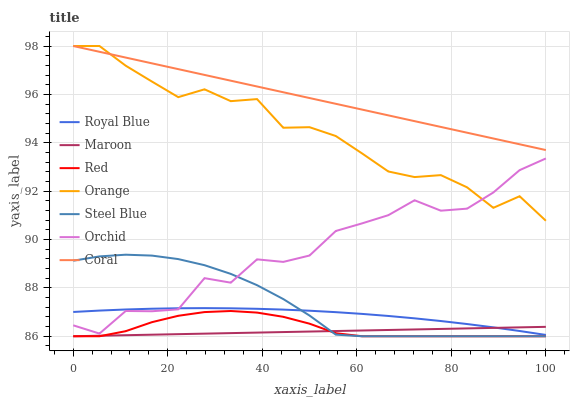Does Maroon have the minimum area under the curve?
Answer yes or no. Yes. Does Coral have the maximum area under the curve?
Answer yes or no. Yes. Does Steel Blue have the minimum area under the curve?
Answer yes or no. No. Does Steel Blue have the maximum area under the curve?
Answer yes or no. No. Is Maroon the smoothest?
Answer yes or no. Yes. Is Orchid the roughest?
Answer yes or no. Yes. Is Steel Blue the smoothest?
Answer yes or no. No. Is Steel Blue the roughest?
Answer yes or no. No. Does Royal Blue have the lowest value?
Answer yes or no. No. Does Orange have the highest value?
Answer yes or no. Yes. Does Steel Blue have the highest value?
Answer yes or no. No. Is Red less than Orchid?
Answer yes or no. Yes. Is Orange greater than Red?
Answer yes or no. Yes. Does Maroon intersect Red?
Answer yes or no. Yes. Is Maroon less than Red?
Answer yes or no. No. Is Maroon greater than Red?
Answer yes or no. No. Does Red intersect Orchid?
Answer yes or no. No. 